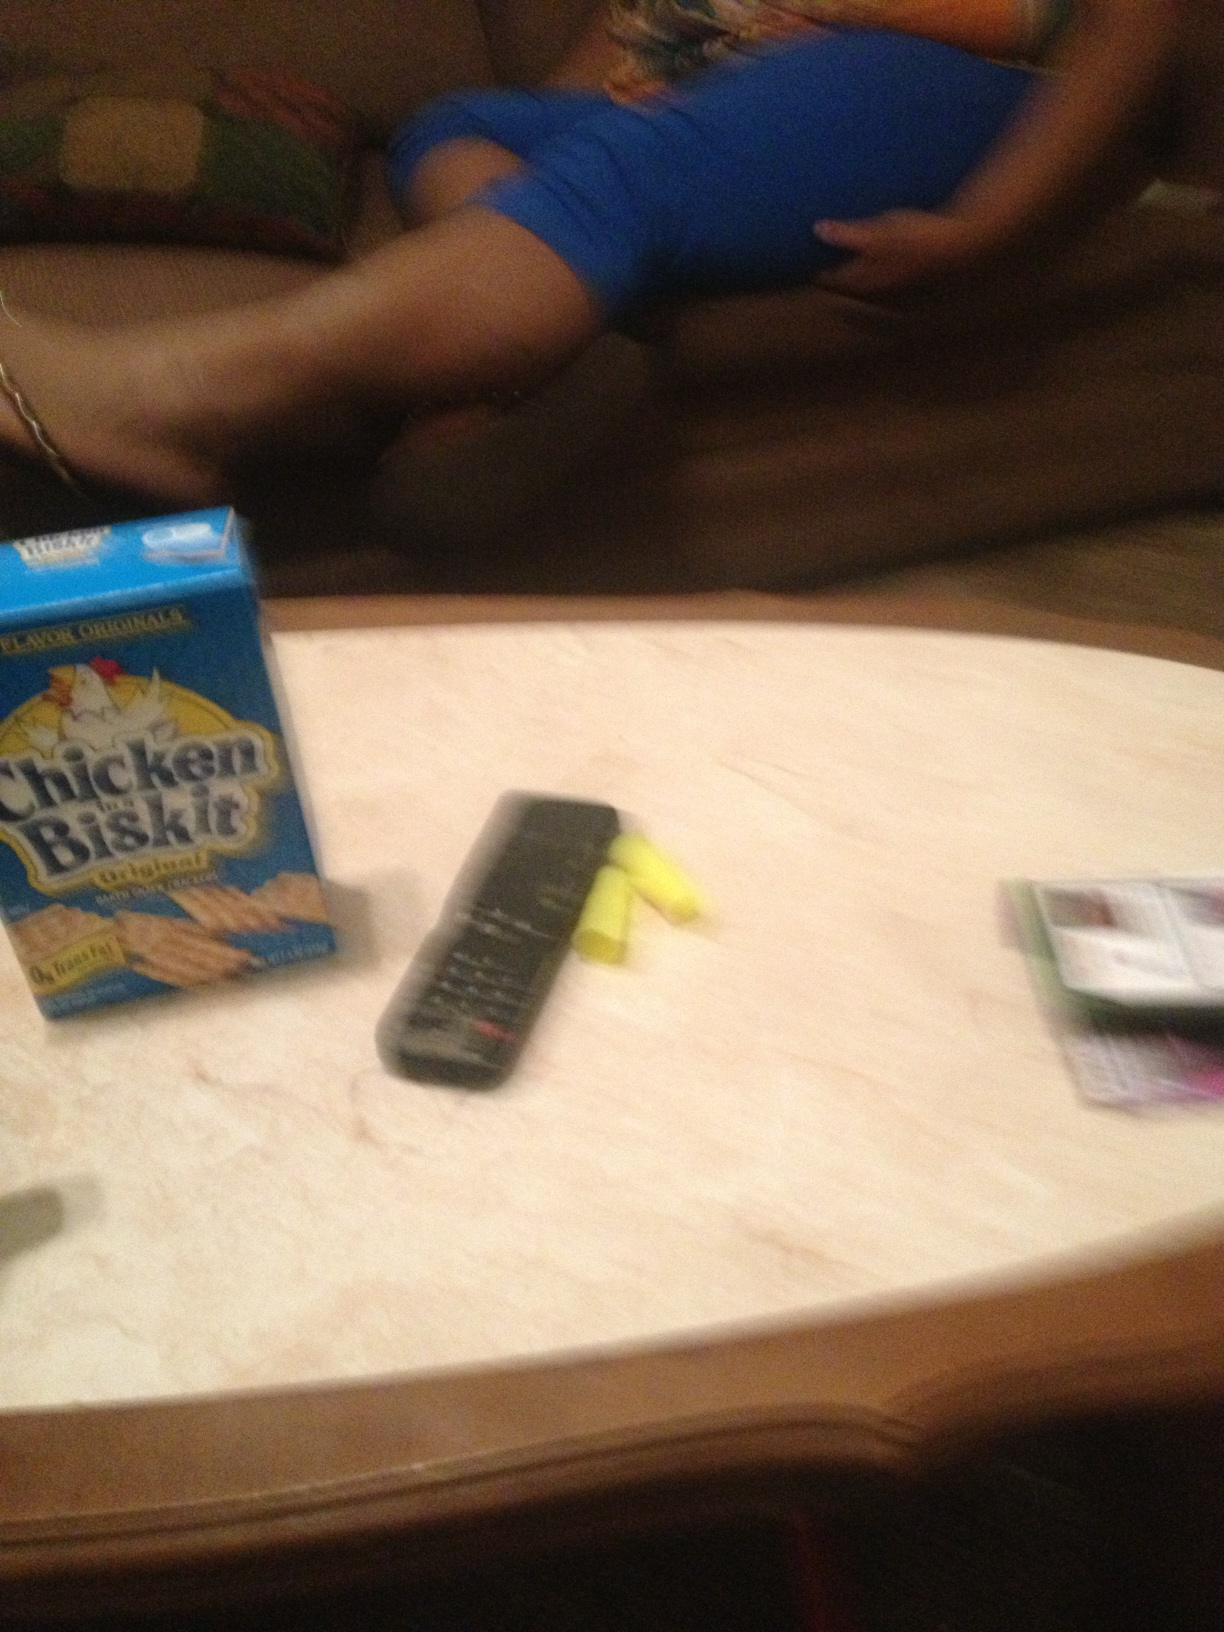Can you tell me more about what's on the table? On the table, there is a blue box of Chicken in a Biskit crackers, a television remote control, and what looks like a small pile of yellow objects which could be highlighters or markers. The items indicate a casual setting, possibly a living room or a recreational area. 